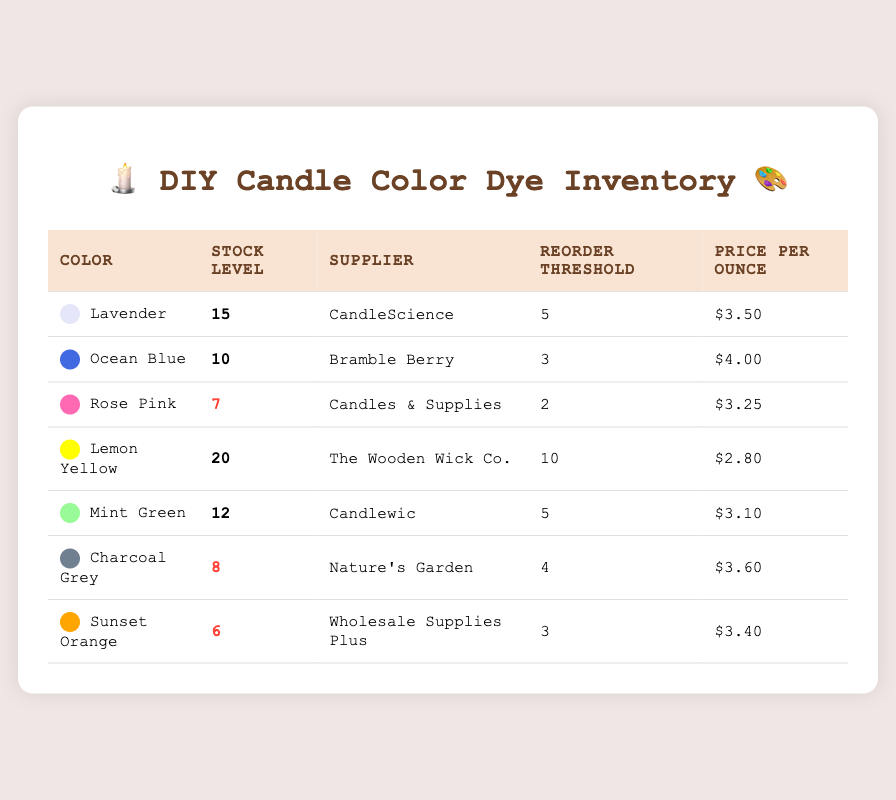What is the stock level of Lavender color dye? The stock level of Lavender can be directly found in the table under the "Stock Level" column corresponding to Lavender in the "Color" column. It shows 15.
Answer: 15 Which supplier provides Ocean Blue color dye? The table lists suppliers in the "Supplier" column next to the corresponding color. For Ocean Blue, the supplier is Bramble Berry.
Answer: Bramble Berry How many colors have stock levels below the reorder threshold? We need to check each color's stock level against its reorder threshold. Rose Pink (7 vs. 2), Charcoal Grey (8 vs. 4), and Sunset Orange (6 vs. 3) are below their thresholds. Thus, there are three colors.
Answer: 3 What is the total stock level of all colors? To find the total stock level, add all stock levels together: 15 (Lavender) + 10 (Ocean Blue) + 7 (Rose Pink) + 20 (Lemon Yellow) + 12 (Mint Green) + 8 (Charcoal Grey) + 6 (Sunset Orange) = 78.
Answer: 78 Is the price per ounce of Lemon Yellow color dye lower than that of Rose Pink? Compare the prices listed in the "Price Per Ounce" column. Lemon Yellow is $2.80 and Rose Pink is $3.25. Since $2.80 is lower than $3.25, the answer is yes.
Answer: Yes What is the average stock level of the colors listed? First, sum all stock levels (15 + 10 + 7 + 20 + 12 + 8 + 6 = 78). Then, divide by the number of colors (7). So, the average is 78 / 7 = 11.14.
Answer: 11.14 Which color dye has the highest stock level, and what is that level? The highest stock level can be found by comparing all entries in the "Stock Level" column. Lemon Yellow has the highest stock level of 20.
Answer: Lemon Yellow, 20 Which colors should be reordered based on the threshold? Check each color against its reorder threshold. Lavender (15 vs. 5), Ocean Blue (10 vs. 3), Lemon Yellow (20 vs. 10) are okay, but Rose Pink (7 vs. 2), Charcoal Grey (8 vs. 4), and Sunset Orange (6 vs. 3) should be reordered due to low levels.
Answer: Rose Pink, Charcoal Grey, Sunset Orange How many colors have a stock level of 10 or higher? Look at the stock levels: Lavender (15), Ocean Blue (10), Lemon Yellow (20), Mint Green (12). That totals four colors with stock levels of 10 or higher.
Answer: 4 